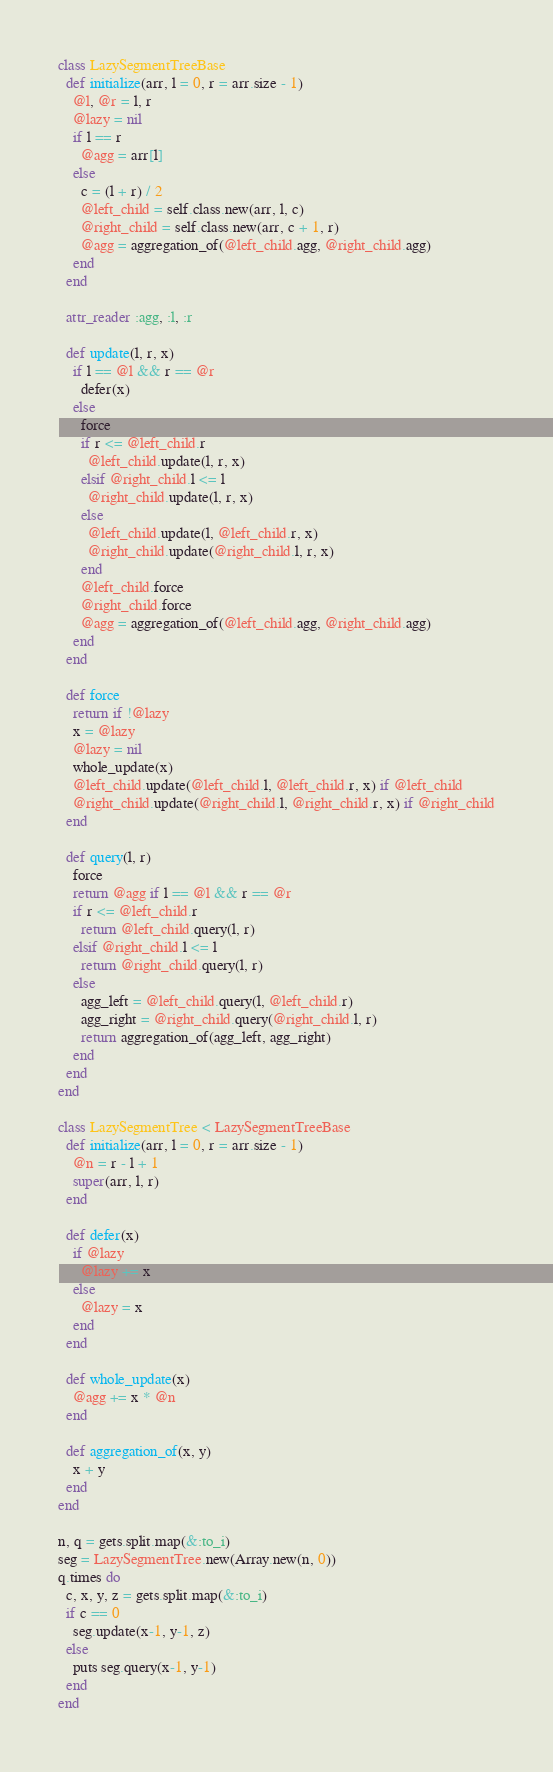Convert code to text. <code><loc_0><loc_0><loc_500><loc_500><_Ruby_>class LazySegmentTreeBase
  def initialize(arr, l = 0, r = arr.size - 1)
    @l, @r = l, r
    @lazy = nil
    if l == r
      @agg = arr[l]
    else
      c = (l + r) / 2
      @left_child = self.class.new(arr, l, c)
      @right_child = self.class.new(arr, c + 1, r)
      @agg = aggregation_of(@left_child.agg, @right_child.agg)
    end
  end

  attr_reader :agg, :l, :r

  def update(l, r, x)
    if l == @l && r == @r
      defer(x)
    else
      force
      if r <= @left_child.r
        @left_child.update(l, r, x)
      elsif @right_child.l <= l
        @right_child.update(l, r, x)
      else
        @left_child.update(l, @left_child.r, x)
        @right_child.update(@right_child.l, r, x)
      end
      @left_child.force
      @right_child.force
      @agg = aggregation_of(@left_child.agg, @right_child.agg)
    end
  end

  def force
    return if !@lazy
    x = @lazy
    @lazy = nil
    whole_update(x)
    @left_child.update(@left_child.l, @left_child.r, x) if @left_child
    @right_child.update(@right_child.l, @right_child.r, x) if @right_child
  end

  def query(l, r)
    force
    return @agg if l == @l && r == @r
    if r <= @left_child.r
      return @left_child.query(l, r)
    elsif @right_child.l <= l
      return @right_child.query(l, r)
    else
      agg_left = @left_child.query(l, @left_child.r)
      agg_right = @right_child.query(@right_child.l, r)
      return aggregation_of(agg_left, agg_right)
    end
  end
end

class LazySegmentTree < LazySegmentTreeBase
  def initialize(arr, l = 0, r = arr.size - 1)
    @n = r - l + 1
    super(arr, l, r)
  end

  def defer(x)
    if @lazy
      @lazy += x
    else
      @lazy = x
    end
  end

  def whole_update(x)
    @agg += x * @n
  end

  def aggregation_of(x, y)
    x + y
  end
end

n, q = gets.split.map(&:to_i)
seg = LazySegmentTree.new(Array.new(n, 0))
q.times do
  c, x, y, z = gets.split.map(&:to_i)
  if c == 0
    seg.update(x-1, y-1, z)
  else
    puts seg.query(x-1, y-1)
  end
end
</code> 